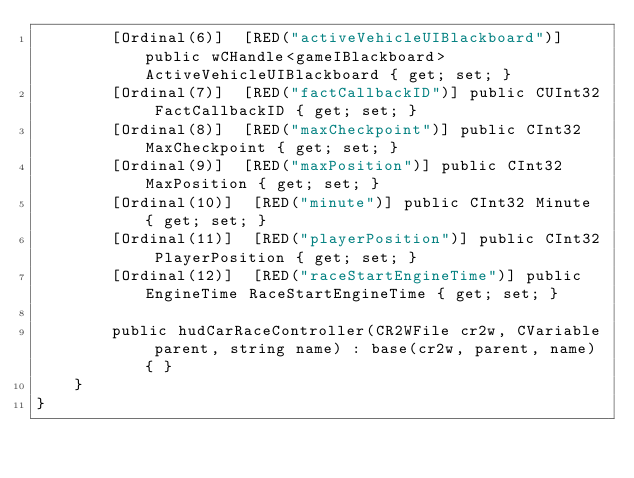Convert code to text. <code><loc_0><loc_0><loc_500><loc_500><_C#_>		[Ordinal(6)]  [RED("activeVehicleUIBlackboard")] public wCHandle<gameIBlackboard> ActiveVehicleUIBlackboard { get; set; }
		[Ordinal(7)]  [RED("factCallbackID")] public CUInt32 FactCallbackID { get; set; }
		[Ordinal(8)]  [RED("maxCheckpoint")] public CInt32 MaxCheckpoint { get; set; }
		[Ordinal(9)]  [RED("maxPosition")] public CInt32 MaxPosition { get; set; }
		[Ordinal(10)]  [RED("minute")] public CInt32 Minute { get; set; }
		[Ordinal(11)]  [RED("playerPosition")] public CInt32 PlayerPosition { get; set; }
		[Ordinal(12)]  [RED("raceStartEngineTime")] public EngineTime RaceStartEngineTime { get; set; }

		public hudCarRaceController(CR2WFile cr2w, CVariable parent, string name) : base(cr2w, parent, name) { }
	}
}
</code> 